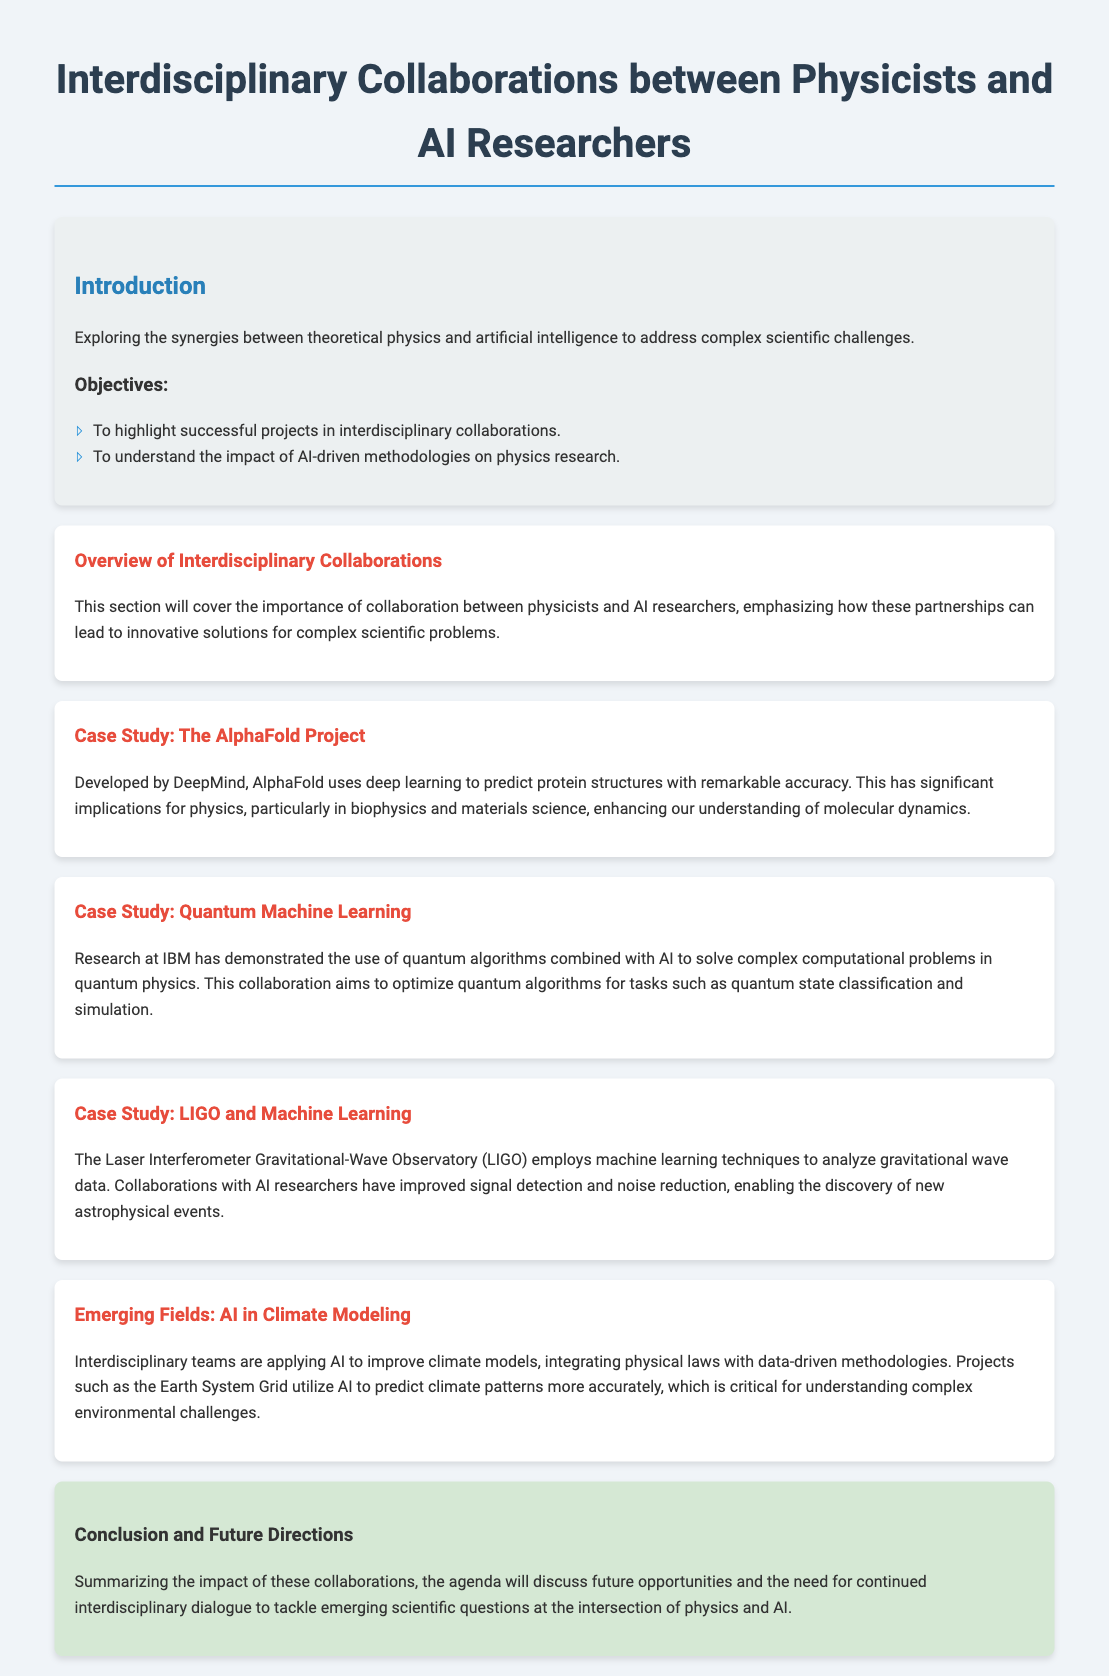What is the title of the agenda? The title is presented in the main header of the document.
Answer: Interdisciplinary Collaborations between Physicists and AI Researchers Who developed AlphaFold? The document mentions the organization that created AlphaFold.
Answer: DeepMind Which project uses machine learning to analyze gravitational wave data? The document describes a specific organization that employs machine learning techniques.
Answer: LIGO What area is emphasized for its integration with AI in climate modeling? The document references the type of modeling improved by AI techniques.
Answer: Climate models What is one objective of the agenda? The document lists the objectives in the introduction section.
Answer: To highlight successful projects in interdisciplinary collaborations How does AI contribute to the AlphaFold project? The document describes the role of AI in the results of AlphaFold.
Answer: Predict protein structures What emerging field is discussed related to applying AI? The document mentions a newly developing application area that combines physics and AI.
Answer: AI in Climate Modeling What implications does AlphaFold have for physics? The document describes the areas of physics impacted by AlphaFold.
Answer: Biophysics and materials science What technique does LIGO employ for noise reduction? The document specifies the method used by LIGO to enhance data analysis.
Answer: Machine learning 